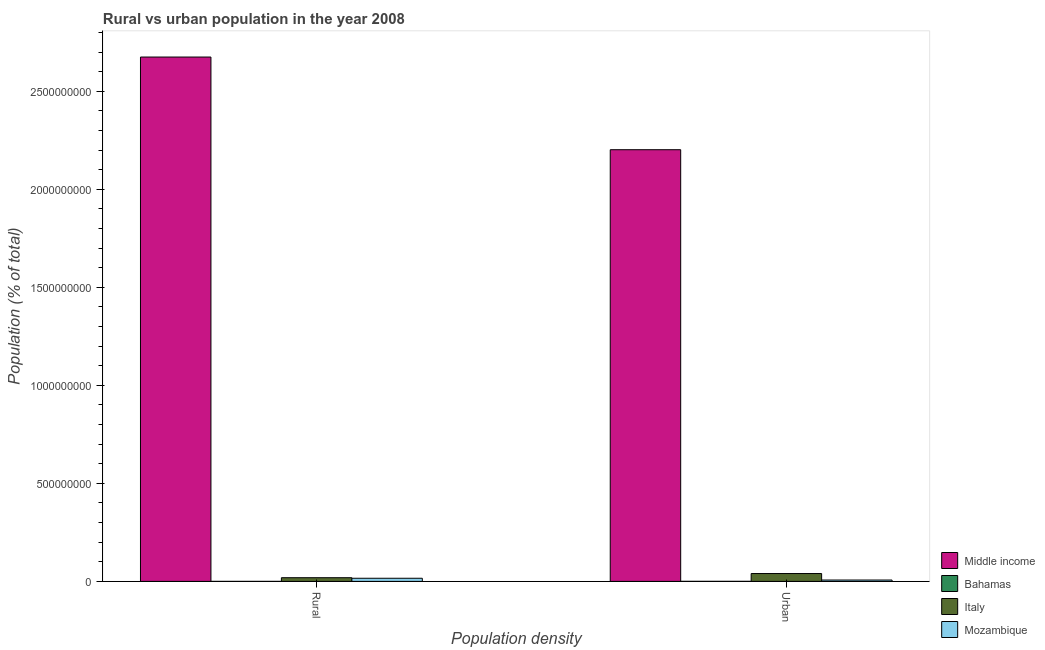How many groups of bars are there?
Offer a very short reply. 2. Are the number of bars per tick equal to the number of legend labels?
Provide a succinct answer. Yes. How many bars are there on the 2nd tick from the left?
Give a very brief answer. 4. What is the label of the 1st group of bars from the left?
Provide a succinct answer. Rural. What is the rural population density in Italy?
Provide a succinct answer. 1.88e+07. Across all countries, what is the maximum rural population density?
Make the answer very short. 2.68e+09. Across all countries, what is the minimum urban population density?
Your response must be concise. 2.87e+05. In which country was the urban population density minimum?
Ensure brevity in your answer.  Bahamas. What is the total rural population density in the graph?
Ensure brevity in your answer.  2.71e+09. What is the difference between the rural population density in Middle income and that in Bahamas?
Your answer should be compact. 2.68e+09. What is the difference between the rural population density in Italy and the urban population density in Mozambique?
Offer a terse response. 1.17e+07. What is the average urban population density per country?
Keep it short and to the point. 5.62e+08. What is the difference between the urban population density and rural population density in Mozambique?
Your answer should be very brief. -8.95e+06. In how many countries, is the rural population density greater than 1200000000 %?
Provide a short and direct response. 1. What is the ratio of the urban population density in Italy to that in Bahamas?
Provide a short and direct response. 139.38. Is the rural population density in Italy less than that in Bahamas?
Your response must be concise. No. What does the 2nd bar from the left in Urban represents?
Ensure brevity in your answer.  Bahamas. What does the 3rd bar from the right in Rural represents?
Your answer should be compact. Bahamas. What is the difference between two consecutive major ticks on the Y-axis?
Your response must be concise. 5.00e+08. Does the graph contain any zero values?
Give a very brief answer. No. Where does the legend appear in the graph?
Make the answer very short. Bottom right. How many legend labels are there?
Your answer should be compact. 4. How are the legend labels stacked?
Give a very brief answer. Vertical. What is the title of the graph?
Offer a very short reply. Rural vs urban population in the year 2008. Does "Norway" appear as one of the legend labels in the graph?
Offer a very short reply. No. What is the label or title of the X-axis?
Provide a succinct answer. Population density. What is the label or title of the Y-axis?
Your answer should be very brief. Population (% of total). What is the Population (% of total) of Middle income in Rural?
Provide a short and direct response. 2.68e+09. What is the Population (% of total) of Bahamas in Rural?
Make the answer very short. 6.12e+04. What is the Population (% of total) of Italy in Rural?
Keep it short and to the point. 1.88e+07. What is the Population (% of total) in Mozambique in Rural?
Make the answer very short. 1.60e+07. What is the Population (% of total) of Middle income in Urban?
Ensure brevity in your answer.  2.20e+09. What is the Population (% of total) in Bahamas in Urban?
Make the answer very short. 2.87e+05. What is the Population (% of total) in Italy in Urban?
Ensure brevity in your answer.  4.01e+07. What is the Population (% of total) in Mozambique in Urban?
Your answer should be compact. 7.02e+06. Across all Population density, what is the maximum Population (% of total) of Middle income?
Provide a short and direct response. 2.68e+09. Across all Population density, what is the maximum Population (% of total) of Bahamas?
Ensure brevity in your answer.  2.87e+05. Across all Population density, what is the maximum Population (% of total) of Italy?
Provide a succinct answer. 4.01e+07. Across all Population density, what is the maximum Population (% of total) of Mozambique?
Keep it short and to the point. 1.60e+07. Across all Population density, what is the minimum Population (% of total) of Middle income?
Give a very brief answer. 2.20e+09. Across all Population density, what is the minimum Population (% of total) of Bahamas?
Provide a short and direct response. 6.12e+04. Across all Population density, what is the minimum Population (% of total) in Italy?
Offer a terse response. 1.88e+07. Across all Population density, what is the minimum Population (% of total) in Mozambique?
Make the answer very short. 7.02e+06. What is the total Population (% of total) of Middle income in the graph?
Offer a terse response. 4.88e+09. What is the total Population (% of total) of Bahamas in the graph?
Your answer should be compact. 3.49e+05. What is the total Population (% of total) of Italy in the graph?
Your response must be concise. 5.88e+07. What is the total Population (% of total) in Mozambique in the graph?
Provide a short and direct response. 2.30e+07. What is the difference between the Population (% of total) of Middle income in Rural and that in Urban?
Provide a short and direct response. 4.73e+08. What is the difference between the Population (% of total) of Bahamas in Rural and that in Urban?
Your answer should be very brief. -2.26e+05. What is the difference between the Population (% of total) in Italy in Rural and that in Urban?
Your response must be concise. -2.13e+07. What is the difference between the Population (% of total) of Mozambique in Rural and that in Urban?
Give a very brief answer. 8.95e+06. What is the difference between the Population (% of total) of Middle income in Rural and the Population (% of total) of Bahamas in Urban?
Your answer should be very brief. 2.67e+09. What is the difference between the Population (% of total) in Middle income in Rural and the Population (% of total) in Italy in Urban?
Give a very brief answer. 2.64e+09. What is the difference between the Population (% of total) of Middle income in Rural and the Population (% of total) of Mozambique in Urban?
Provide a short and direct response. 2.67e+09. What is the difference between the Population (% of total) in Bahamas in Rural and the Population (% of total) in Italy in Urban?
Make the answer very short. -4.00e+07. What is the difference between the Population (% of total) of Bahamas in Rural and the Population (% of total) of Mozambique in Urban?
Provide a succinct answer. -6.96e+06. What is the difference between the Population (% of total) in Italy in Rural and the Population (% of total) in Mozambique in Urban?
Keep it short and to the point. 1.17e+07. What is the average Population (% of total) of Middle income per Population density?
Give a very brief answer. 2.44e+09. What is the average Population (% of total) in Bahamas per Population density?
Your response must be concise. 1.74e+05. What is the average Population (% of total) in Italy per Population density?
Your answer should be very brief. 2.94e+07. What is the average Population (% of total) of Mozambique per Population density?
Your answer should be very brief. 1.15e+07. What is the difference between the Population (% of total) of Middle income and Population (% of total) of Bahamas in Rural?
Offer a very short reply. 2.68e+09. What is the difference between the Population (% of total) of Middle income and Population (% of total) of Italy in Rural?
Offer a terse response. 2.66e+09. What is the difference between the Population (% of total) of Middle income and Population (% of total) of Mozambique in Rural?
Ensure brevity in your answer.  2.66e+09. What is the difference between the Population (% of total) in Bahamas and Population (% of total) in Italy in Rural?
Your answer should be compact. -1.87e+07. What is the difference between the Population (% of total) of Bahamas and Population (% of total) of Mozambique in Rural?
Offer a very short reply. -1.59e+07. What is the difference between the Population (% of total) in Italy and Population (% of total) in Mozambique in Rural?
Offer a terse response. 2.80e+06. What is the difference between the Population (% of total) in Middle income and Population (% of total) in Bahamas in Urban?
Your answer should be very brief. 2.20e+09. What is the difference between the Population (% of total) in Middle income and Population (% of total) in Italy in Urban?
Offer a terse response. 2.16e+09. What is the difference between the Population (% of total) of Middle income and Population (% of total) of Mozambique in Urban?
Give a very brief answer. 2.20e+09. What is the difference between the Population (% of total) of Bahamas and Population (% of total) of Italy in Urban?
Keep it short and to the point. -3.98e+07. What is the difference between the Population (% of total) of Bahamas and Population (% of total) of Mozambique in Urban?
Provide a succinct answer. -6.74e+06. What is the difference between the Population (% of total) of Italy and Population (% of total) of Mozambique in Urban?
Your answer should be very brief. 3.30e+07. What is the ratio of the Population (% of total) in Middle income in Rural to that in Urban?
Your answer should be very brief. 1.21. What is the ratio of the Population (% of total) in Bahamas in Rural to that in Urban?
Offer a terse response. 0.21. What is the ratio of the Population (% of total) of Italy in Rural to that in Urban?
Offer a very short reply. 0.47. What is the ratio of the Population (% of total) in Mozambique in Rural to that in Urban?
Your answer should be very brief. 2.27. What is the difference between the highest and the second highest Population (% of total) in Middle income?
Your response must be concise. 4.73e+08. What is the difference between the highest and the second highest Population (% of total) of Bahamas?
Offer a very short reply. 2.26e+05. What is the difference between the highest and the second highest Population (% of total) of Italy?
Make the answer very short. 2.13e+07. What is the difference between the highest and the second highest Population (% of total) of Mozambique?
Provide a short and direct response. 8.95e+06. What is the difference between the highest and the lowest Population (% of total) of Middle income?
Make the answer very short. 4.73e+08. What is the difference between the highest and the lowest Population (% of total) in Bahamas?
Your answer should be compact. 2.26e+05. What is the difference between the highest and the lowest Population (% of total) in Italy?
Make the answer very short. 2.13e+07. What is the difference between the highest and the lowest Population (% of total) of Mozambique?
Make the answer very short. 8.95e+06. 